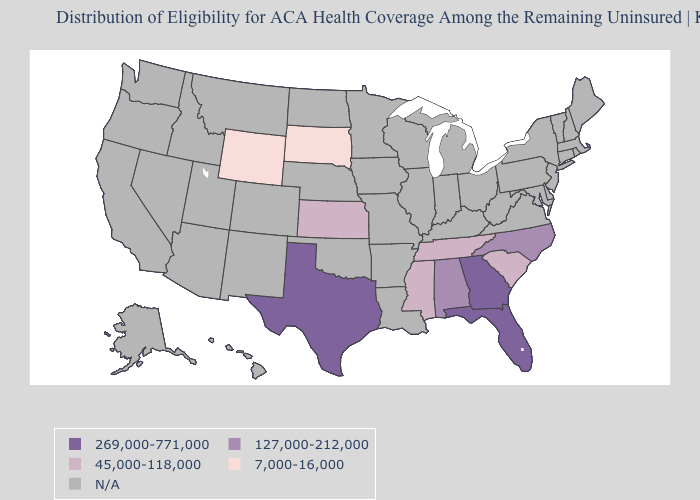Does Texas have the highest value in the USA?
Keep it brief. Yes. What is the value of Maine?
Short answer required. N/A. What is the value of Iowa?
Give a very brief answer. N/A. What is the value of Nevada?
Quick response, please. N/A. Which states have the lowest value in the USA?
Write a very short answer. South Dakota, Wyoming. Name the states that have a value in the range 269,000-771,000?
Short answer required. Florida, Georgia, Texas. Name the states that have a value in the range 45,000-118,000?
Write a very short answer. Kansas, Mississippi, South Carolina, Tennessee. What is the lowest value in the South?
Answer briefly. 45,000-118,000. Which states hav the highest value in the West?
Answer briefly. Wyoming. Which states have the lowest value in the South?
Answer briefly. Mississippi, South Carolina, Tennessee. Which states have the lowest value in the South?
Write a very short answer. Mississippi, South Carolina, Tennessee. What is the highest value in the West ?
Keep it brief. 7,000-16,000. Name the states that have a value in the range 45,000-118,000?
Quick response, please. Kansas, Mississippi, South Carolina, Tennessee. What is the value of Connecticut?
Answer briefly. N/A. 